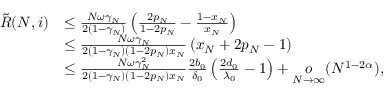Convert formula to latex. <formula><loc_0><loc_0><loc_500><loc_500>\begin{array} { r l } { \tilde { R } ( N , i ) } & { \leq \frac { N \omega \gamma _ { N } } { 2 ( 1 - \gamma _ { N } ) } \left ( \frac { 2 p _ { N } } { 1 - 2 p _ { N } } - \frac { 1 - x _ { N } } { x _ { N } } \right ) } \\ & { \leq \frac { N \omega \gamma _ { N } } { 2 ( 1 - \gamma _ { N } ) ( 1 - 2 p _ { N } ) x _ { N } } \left ( x _ { N } + 2 p _ { N } - 1 \right ) } \\ & { \leq \frac { N \omega \gamma _ { N } ^ { 2 } } { 2 ( 1 - \gamma _ { N } ) ( 1 - 2 p _ { N } ) x _ { N } } \frac { 2 b _ { 0 } } { \delta _ { 0 } } \left ( \frac { 2 d _ { 0 } } { \lambda _ { 0 } } - 1 \right ) + \underset { N \to \infty } { o } ( N ^ { 1 - 2 \alpha } ) , } \end{array}</formula> 